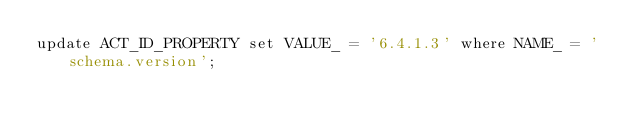Convert code to text. <code><loc_0><loc_0><loc_500><loc_500><_SQL_>update ACT_ID_PROPERTY set VALUE_ = '6.4.1.3' where NAME_ = 'schema.version';
</code> 